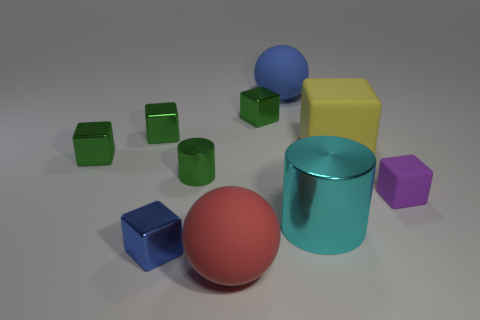Subtract all rubber cubes. How many cubes are left? 4 Subtract all purple cubes. How many cubes are left? 5 Subtract 1 cylinders. How many cylinders are left? 1 Subtract all spheres. How many objects are left? 8 Subtract all gray balls. How many green cubes are left? 3 Subtract all big brown rubber balls. Subtract all tiny rubber things. How many objects are left? 9 Add 6 small rubber blocks. How many small rubber blocks are left? 7 Add 8 tiny purple matte cubes. How many tiny purple matte cubes exist? 9 Subtract 1 blue spheres. How many objects are left? 9 Subtract all blue cubes. Subtract all red cylinders. How many cubes are left? 5 